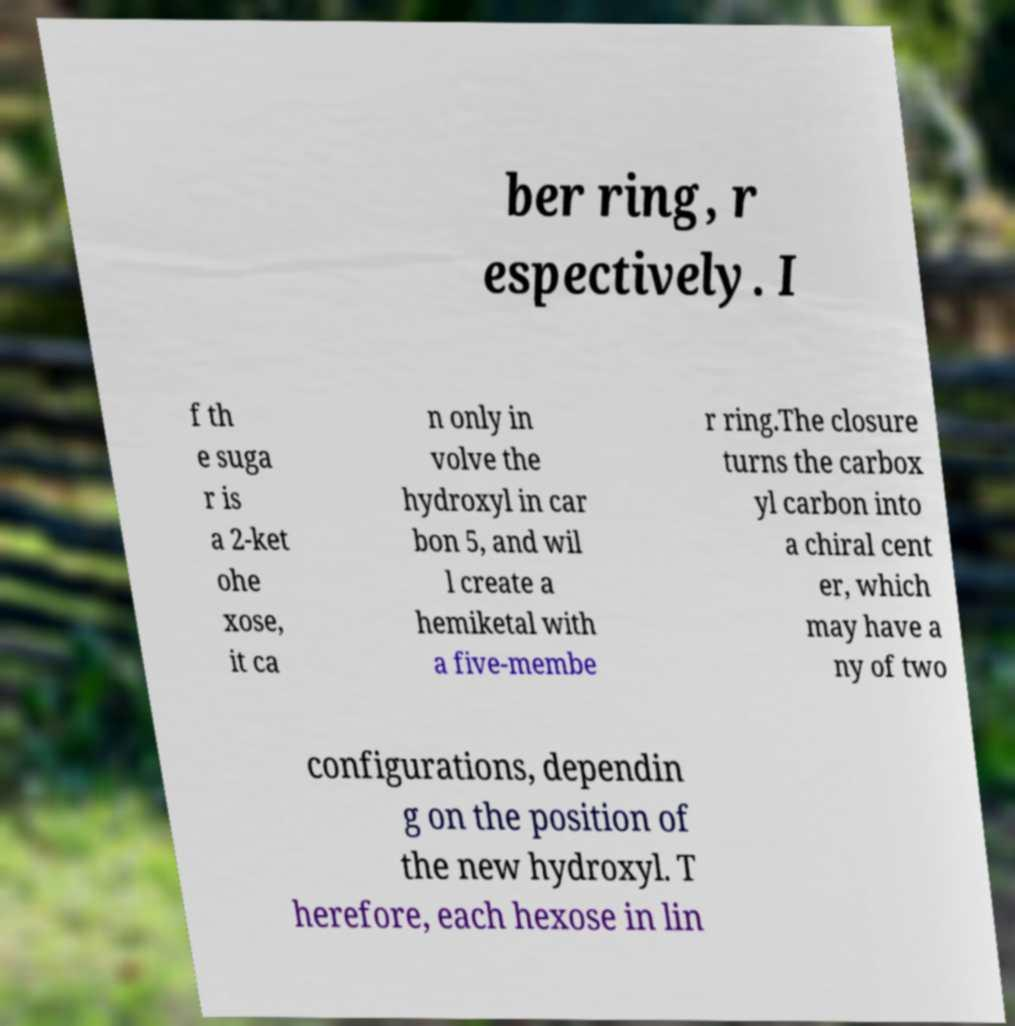Please identify and transcribe the text found in this image. ber ring, r espectively. I f th e suga r is a 2-ket ohe xose, it ca n only in volve the hydroxyl in car bon 5, and wil l create a hemiketal with a five-membe r ring.The closure turns the carbox yl carbon into a chiral cent er, which may have a ny of two configurations, dependin g on the position of the new hydroxyl. T herefore, each hexose in lin 